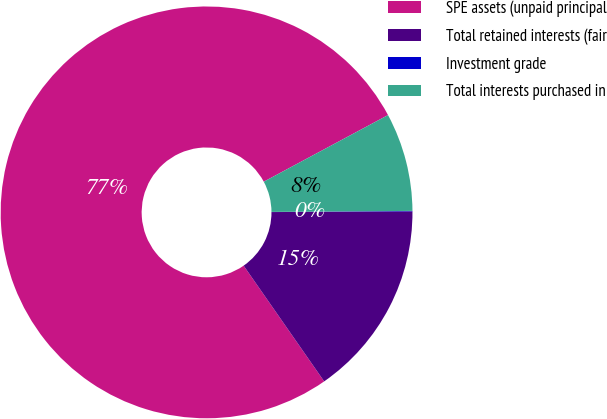<chart> <loc_0><loc_0><loc_500><loc_500><pie_chart><fcel>SPE assets (unpaid principal<fcel>Total retained interests (fair<fcel>Investment grade<fcel>Total interests purchased in<nl><fcel>76.85%<fcel>15.4%<fcel>0.04%<fcel>7.72%<nl></chart> 